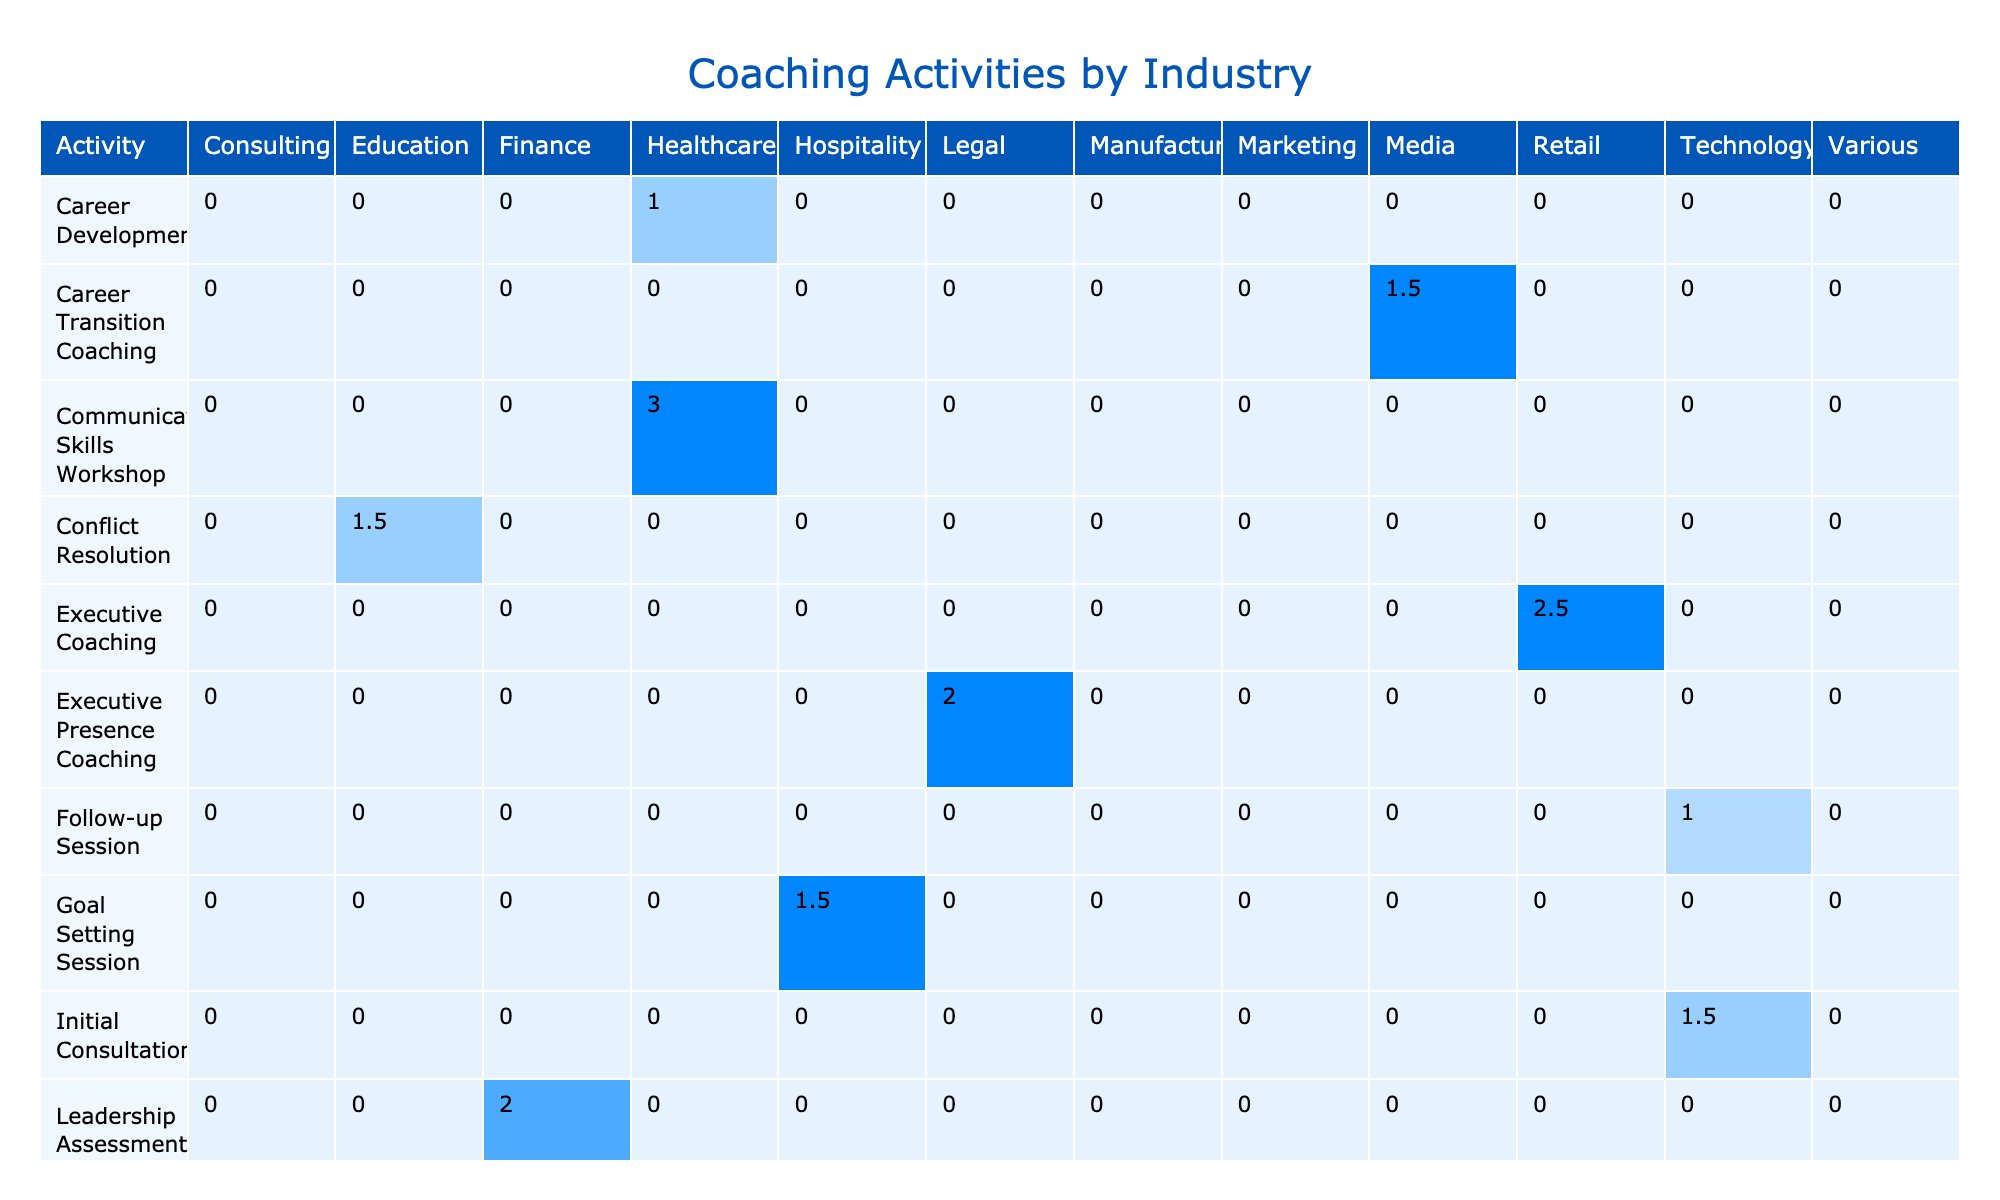What is the duration of the "Career Development" activity? The table lists the "Career Development" activity under the Activity column, showing a duration of 1 hour in the corresponding row.
Answer: 1 hour Which industry had the longest coaching session duration? To find this, I check the maximum values in each industry column. "Education" has a session "Stress Management Seminar" lasting 3.5 hours, which is the highest duration.
Answer: Education How many total hours were spent on "One-on-One" sessions? I need to identify all "One-on-One" sessions from the table and sum their durations: 1.5 (Initial Consultation) + 2 (Leadership Coaching) + 1 (Career Development) + 1 (Follow-up Session) + 2.5 (Executive Coaching) + 1.5 (Conflict Resolution) + 1 (Mentoring Session) + 2 (Performance Review Coaching) + 1.5 (Goal Setting Session) + 1.5 (Career Transition Coaching) + 2 (Executive Presence Coaching) = 16.5 hours.
Answer: 16.5 hours Is there a "Networking Event" in the table? I can scan the Activities in the table and confirm that "Networking Event" is included in the list, thus the answer is yes.
Answer: Yes What is the average duration of all "Group" activities? I identify all "Group" activities along with their durations: 3 (Workshop Preparation) + 4 (Team Building Workshop) + 3 (Communication Skills Workshop) + 3.5 (Stress Management Seminar) + 2.5 (Networking Event) + 3 (Time Management Workshop) + 3 (Team Performance Review) = 18 hours. There are 7 Group activities, so the average is calculated as 18/7, which equals approximately 2.57 hours.
Answer: Approximately 2.57 hours How many activities were conducted in the "Technology" industry? I can count the "Technology" activities listed in the table: "Initial Consultation," "Team Building Workshop," "Communication Skills Workshop," "Time Management Workshop," which totals to 4 activities.
Answer: 4 activities Which "Client" had the most hours of coaching? I need to add up the total duration for each client. For "Sarah Johnson" (1.5 + 1 = 2.5 hours), "Michael Chen" (2 + 2 = 4 hours), "Emily Rodriguez" (1 hours), "David Thompson" (2.5 hours), "Lisa Patel" (1.5 hours), "Jennifer Lee" (2 hours), "Robert Garcia" (1.5 hours), "Emma Watson" (1.5 hours), and "Olivia Martinez" (2 hours). The highest total is for Michael Chen, with 4 hours.
Answer: Michael Chen What is the total duration of "In-Person" sessions? I will sum up all durations associated with "In-Person" in the Location column: 2 (Leadership Coaching) + 4 (Team Building Workshop) + 2.5 (Executive Coaching) + 1 (Mentoring Session) + 2 (Leadership Assessment) + 2.5 (Networking Event) + 3 (Time Management Workshop) = 16 hours.
Answer: 16 hours How many unique clients did not have any "Group" sessions? I review the table for unique clients with only "One-on-One" sessions. The clients for the "Group" sessions are "TechCorp Inc.," "GlobalHealth Ltd.," "EduTech Solutions," "InnovateTech Inc.," and "FinanceFirst Corp." Thus, unique clients like "Sarah Johnson," "Michael Chen," "Emily Rodriguez," "David Thompson," etc., don’t have any "Group" sessions, totaling 8 unique clients.
Answer: 8 unique clients 